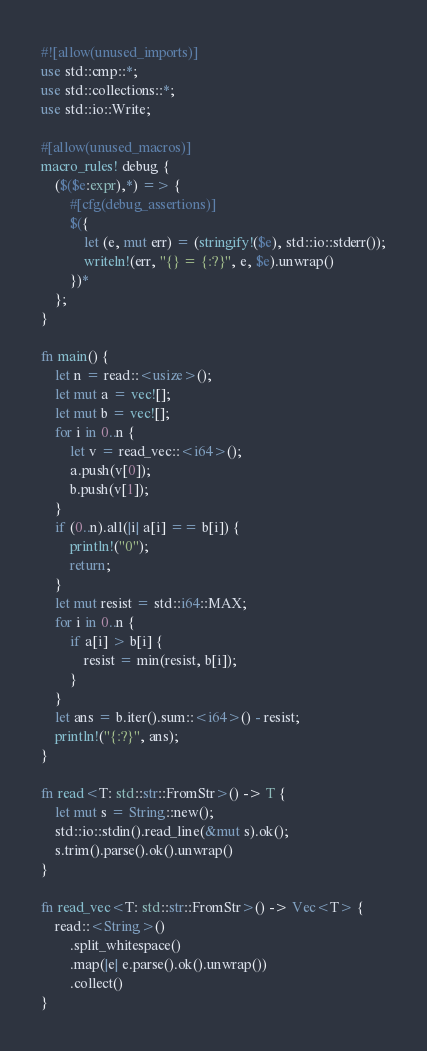Convert code to text. <code><loc_0><loc_0><loc_500><loc_500><_Rust_>#![allow(unused_imports)]
use std::cmp::*;
use std::collections::*;
use std::io::Write;

#[allow(unused_macros)]
macro_rules! debug {
    ($($e:expr),*) => {
        #[cfg(debug_assertions)]
        $({
            let (e, mut err) = (stringify!($e), std::io::stderr());
            writeln!(err, "{} = {:?}", e, $e).unwrap()
        })*
    };
}

fn main() {
    let n = read::<usize>();
    let mut a = vec![];
    let mut b = vec![];
    for i in 0..n {
        let v = read_vec::<i64>();
        a.push(v[0]);
        b.push(v[1]);
    }
    if (0..n).all(|i| a[i] == b[i]) {
        println!("0");
        return;
    }
    let mut resist = std::i64::MAX;
    for i in 0..n {
        if a[i] > b[i] {
            resist = min(resist, b[i]);
        }
    }
    let ans = b.iter().sum::<i64>() - resist;
    println!("{:?}", ans);
}

fn read<T: std::str::FromStr>() -> T {
    let mut s = String::new();
    std::io::stdin().read_line(&mut s).ok();
    s.trim().parse().ok().unwrap()
}

fn read_vec<T: std::str::FromStr>() -> Vec<T> {
    read::<String>()
        .split_whitespace()
        .map(|e| e.parse().ok().unwrap())
        .collect()
}
</code> 